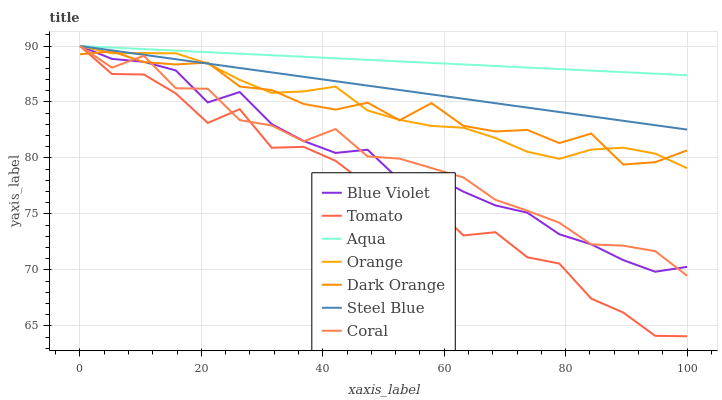Does Tomato have the minimum area under the curve?
Answer yes or no. Yes. Does Aqua have the maximum area under the curve?
Answer yes or no. Yes. Does Dark Orange have the minimum area under the curve?
Answer yes or no. No. Does Dark Orange have the maximum area under the curve?
Answer yes or no. No. Is Steel Blue the smoothest?
Answer yes or no. Yes. Is Tomato the roughest?
Answer yes or no. Yes. Is Dark Orange the smoothest?
Answer yes or no. No. Is Dark Orange the roughest?
Answer yes or no. No. Does Dark Orange have the lowest value?
Answer yes or no. No. Does Blue Violet have the highest value?
Answer yes or no. Yes. Does Dark Orange have the highest value?
Answer yes or no. No. Is Dark Orange less than Aqua?
Answer yes or no. Yes. Is Aqua greater than Dark Orange?
Answer yes or no. Yes. Does Dark Orange intersect Aqua?
Answer yes or no. No. 